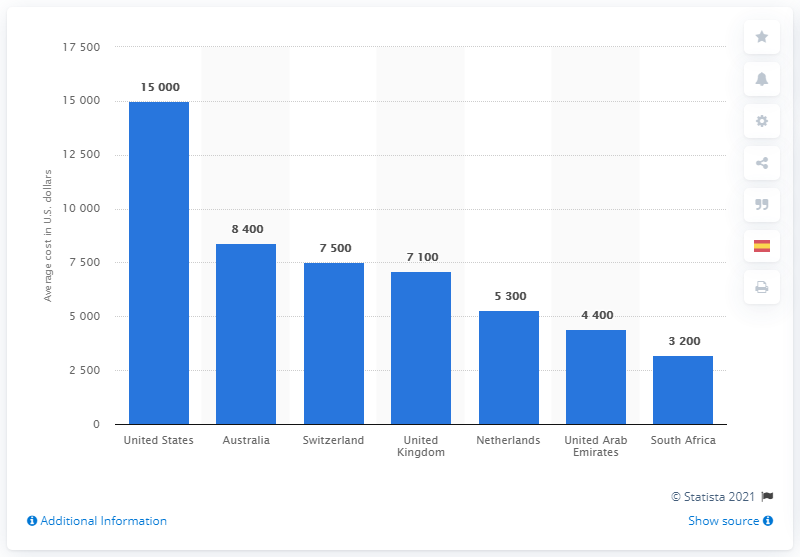Specify some key components in this picture. The cost of a C-section delivery in the United States in 2017 was approximately 15,000 dollars. I'm sorry, but I'm not certain what the original sentence means. Could you please provide more context or clarify your question? The difference between the highest and the lowest blue bar is 11800. 